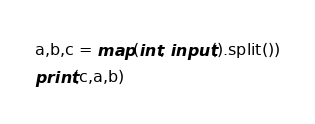<code> <loc_0><loc_0><loc_500><loc_500><_Python_>a,b,c = map(int, input().split())
print(c,a,b)</code> 